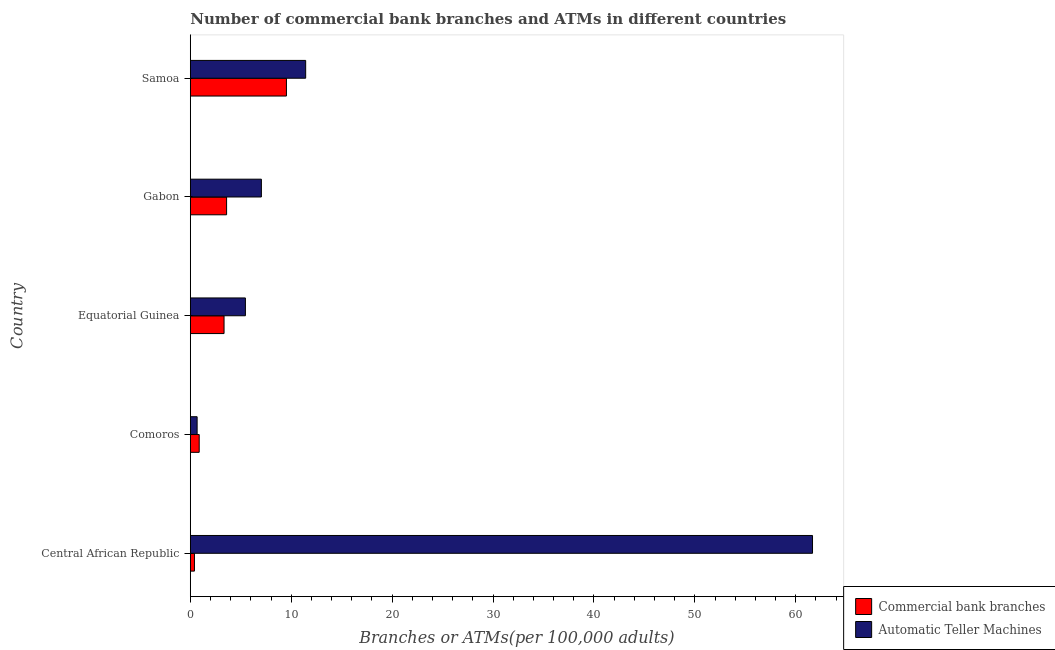Are the number of bars on each tick of the Y-axis equal?
Your response must be concise. Yes. How many bars are there on the 2nd tick from the top?
Make the answer very short. 2. What is the label of the 4th group of bars from the top?
Provide a succinct answer. Comoros. In how many cases, is the number of bars for a given country not equal to the number of legend labels?
Offer a very short reply. 0. What is the number of commercal bank branches in Central African Republic?
Offer a very short reply. 0.41. Across all countries, what is the maximum number of atms?
Your answer should be very brief. 61.66. Across all countries, what is the minimum number of atms?
Offer a very short reply. 0.68. In which country was the number of commercal bank branches maximum?
Give a very brief answer. Samoa. In which country was the number of atms minimum?
Your answer should be compact. Comoros. What is the total number of commercal bank branches in the graph?
Your response must be concise. 17.76. What is the difference between the number of commercal bank branches in Comoros and that in Equatorial Guinea?
Offer a very short reply. -2.46. What is the difference between the number of commercal bank branches in Equatorial Guinea and the number of atms in Central African Republic?
Offer a terse response. -58.31. What is the average number of commercal bank branches per country?
Your answer should be very brief. 3.55. What is the difference between the number of commercal bank branches and number of atms in Central African Republic?
Provide a succinct answer. -61.25. What is the ratio of the number of atms in Comoros to that in Samoa?
Your answer should be compact. 0.06. What is the difference between the highest and the second highest number of commercal bank branches?
Your response must be concise. 5.93. What is the difference between the highest and the lowest number of commercal bank branches?
Keep it short and to the point. 9.12. In how many countries, is the number of atms greater than the average number of atms taken over all countries?
Provide a short and direct response. 1. What does the 2nd bar from the top in Central African Republic represents?
Your response must be concise. Commercial bank branches. What does the 2nd bar from the bottom in Comoros represents?
Your answer should be compact. Automatic Teller Machines. Are all the bars in the graph horizontal?
Make the answer very short. Yes. What is the difference between two consecutive major ticks on the X-axis?
Ensure brevity in your answer.  10. Does the graph contain grids?
Your response must be concise. No. How are the legend labels stacked?
Your answer should be very brief. Vertical. What is the title of the graph?
Make the answer very short. Number of commercial bank branches and ATMs in different countries. Does "Net National savings" appear as one of the legend labels in the graph?
Give a very brief answer. No. What is the label or title of the X-axis?
Give a very brief answer. Branches or ATMs(per 100,0 adults). What is the label or title of the Y-axis?
Your answer should be very brief. Country. What is the Branches or ATMs(per 100,000 adults) of Commercial bank branches in Central African Republic?
Offer a very short reply. 0.41. What is the Branches or ATMs(per 100,000 adults) of Automatic Teller Machines in Central African Republic?
Ensure brevity in your answer.  61.66. What is the Branches or ATMs(per 100,000 adults) of Commercial bank branches in Comoros?
Ensure brevity in your answer.  0.88. What is the Branches or ATMs(per 100,000 adults) in Automatic Teller Machines in Comoros?
Offer a terse response. 0.68. What is the Branches or ATMs(per 100,000 adults) in Commercial bank branches in Equatorial Guinea?
Your answer should be very brief. 3.35. What is the Branches or ATMs(per 100,000 adults) in Automatic Teller Machines in Equatorial Guinea?
Make the answer very short. 5.46. What is the Branches or ATMs(per 100,000 adults) in Commercial bank branches in Gabon?
Make the answer very short. 3.6. What is the Branches or ATMs(per 100,000 adults) in Automatic Teller Machines in Gabon?
Give a very brief answer. 7.04. What is the Branches or ATMs(per 100,000 adults) of Commercial bank branches in Samoa?
Provide a succinct answer. 9.53. What is the Branches or ATMs(per 100,000 adults) of Automatic Teller Machines in Samoa?
Provide a short and direct response. 11.43. Across all countries, what is the maximum Branches or ATMs(per 100,000 adults) in Commercial bank branches?
Your answer should be compact. 9.53. Across all countries, what is the maximum Branches or ATMs(per 100,000 adults) of Automatic Teller Machines?
Offer a terse response. 61.66. Across all countries, what is the minimum Branches or ATMs(per 100,000 adults) in Commercial bank branches?
Offer a very short reply. 0.41. Across all countries, what is the minimum Branches or ATMs(per 100,000 adults) in Automatic Teller Machines?
Keep it short and to the point. 0.68. What is the total Branches or ATMs(per 100,000 adults) of Commercial bank branches in the graph?
Make the answer very short. 17.76. What is the total Branches or ATMs(per 100,000 adults) of Automatic Teller Machines in the graph?
Your response must be concise. 86.27. What is the difference between the Branches or ATMs(per 100,000 adults) of Commercial bank branches in Central African Republic and that in Comoros?
Keep it short and to the point. -0.47. What is the difference between the Branches or ATMs(per 100,000 adults) of Automatic Teller Machines in Central African Republic and that in Comoros?
Make the answer very short. 60.98. What is the difference between the Branches or ATMs(per 100,000 adults) of Commercial bank branches in Central African Republic and that in Equatorial Guinea?
Keep it short and to the point. -2.93. What is the difference between the Branches or ATMs(per 100,000 adults) in Automatic Teller Machines in Central African Republic and that in Equatorial Guinea?
Your response must be concise. 56.2. What is the difference between the Branches or ATMs(per 100,000 adults) of Commercial bank branches in Central African Republic and that in Gabon?
Make the answer very short. -3.19. What is the difference between the Branches or ATMs(per 100,000 adults) in Automatic Teller Machines in Central African Republic and that in Gabon?
Offer a terse response. 54.61. What is the difference between the Branches or ATMs(per 100,000 adults) of Commercial bank branches in Central African Republic and that in Samoa?
Ensure brevity in your answer.  -9.12. What is the difference between the Branches or ATMs(per 100,000 adults) of Automatic Teller Machines in Central African Republic and that in Samoa?
Ensure brevity in your answer.  50.22. What is the difference between the Branches or ATMs(per 100,000 adults) of Commercial bank branches in Comoros and that in Equatorial Guinea?
Keep it short and to the point. -2.46. What is the difference between the Branches or ATMs(per 100,000 adults) of Automatic Teller Machines in Comoros and that in Equatorial Guinea?
Offer a very short reply. -4.79. What is the difference between the Branches or ATMs(per 100,000 adults) in Commercial bank branches in Comoros and that in Gabon?
Your answer should be very brief. -2.71. What is the difference between the Branches or ATMs(per 100,000 adults) of Automatic Teller Machines in Comoros and that in Gabon?
Provide a succinct answer. -6.37. What is the difference between the Branches or ATMs(per 100,000 adults) in Commercial bank branches in Comoros and that in Samoa?
Provide a short and direct response. -8.64. What is the difference between the Branches or ATMs(per 100,000 adults) in Automatic Teller Machines in Comoros and that in Samoa?
Keep it short and to the point. -10.76. What is the difference between the Branches or ATMs(per 100,000 adults) in Commercial bank branches in Equatorial Guinea and that in Gabon?
Your answer should be very brief. -0.25. What is the difference between the Branches or ATMs(per 100,000 adults) of Automatic Teller Machines in Equatorial Guinea and that in Gabon?
Give a very brief answer. -1.58. What is the difference between the Branches or ATMs(per 100,000 adults) in Commercial bank branches in Equatorial Guinea and that in Samoa?
Your answer should be very brief. -6.18. What is the difference between the Branches or ATMs(per 100,000 adults) of Automatic Teller Machines in Equatorial Guinea and that in Samoa?
Keep it short and to the point. -5.97. What is the difference between the Branches or ATMs(per 100,000 adults) in Commercial bank branches in Gabon and that in Samoa?
Your answer should be very brief. -5.93. What is the difference between the Branches or ATMs(per 100,000 adults) in Automatic Teller Machines in Gabon and that in Samoa?
Provide a succinct answer. -4.39. What is the difference between the Branches or ATMs(per 100,000 adults) in Commercial bank branches in Central African Republic and the Branches or ATMs(per 100,000 adults) in Automatic Teller Machines in Comoros?
Make the answer very short. -0.26. What is the difference between the Branches or ATMs(per 100,000 adults) in Commercial bank branches in Central African Republic and the Branches or ATMs(per 100,000 adults) in Automatic Teller Machines in Equatorial Guinea?
Offer a very short reply. -5.05. What is the difference between the Branches or ATMs(per 100,000 adults) of Commercial bank branches in Central African Republic and the Branches or ATMs(per 100,000 adults) of Automatic Teller Machines in Gabon?
Give a very brief answer. -6.63. What is the difference between the Branches or ATMs(per 100,000 adults) in Commercial bank branches in Central African Republic and the Branches or ATMs(per 100,000 adults) in Automatic Teller Machines in Samoa?
Your response must be concise. -11.02. What is the difference between the Branches or ATMs(per 100,000 adults) of Commercial bank branches in Comoros and the Branches or ATMs(per 100,000 adults) of Automatic Teller Machines in Equatorial Guinea?
Offer a terse response. -4.58. What is the difference between the Branches or ATMs(per 100,000 adults) of Commercial bank branches in Comoros and the Branches or ATMs(per 100,000 adults) of Automatic Teller Machines in Gabon?
Make the answer very short. -6.16. What is the difference between the Branches or ATMs(per 100,000 adults) of Commercial bank branches in Comoros and the Branches or ATMs(per 100,000 adults) of Automatic Teller Machines in Samoa?
Your answer should be compact. -10.55. What is the difference between the Branches or ATMs(per 100,000 adults) of Commercial bank branches in Equatorial Guinea and the Branches or ATMs(per 100,000 adults) of Automatic Teller Machines in Gabon?
Make the answer very short. -3.7. What is the difference between the Branches or ATMs(per 100,000 adults) of Commercial bank branches in Equatorial Guinea and the Branches or ATMs(per 100,000 adults) of Automatic Teller Machines in Samoa?
Provide a short and direct response. -8.09. What is the difference between the Branches or ATMs(per 100,000 adults) in Commercial bank branches in Gabon and the Branches or ATMs(per 100,000 adults) in Automatic Teller Machines in Samoa?
Give a very brief answer. -7.84. What is the average Branches or ATMs(per 100,000 adults) of Commercial bank branches per country?
Offer a terse response. 3.55. What is the average Branches or ATMs(per 100,000 adults) in Automatic Teller Machines per country?
Give a very brief answer. 17.25. What is the difference between the Branches or ATMs(per 100,000 adults) in Commercial bank branches and Branches or ATMs(per 100,000 adults) in Automatic Teller Machines in Central African Republic?
Give a very brief answer. -61.25. What is the difference between the Branches or ATMs(per 100,000 adults) of Commercial bank branches and Branches or ATMs(per 100,000 adults) of Automatic Teller Machines in Comoros?
Keep it short and to the point. 0.21. What is the difference between the Branches or ATMs(per 100,000 adults) in Commercial bank branches and Branches or ATMs(per 100,000 adults) in Automatic Teller Machines in Equatorial Guinea?
Give a very brief answer. -2.12. What is the difference between the Branches or ATMs(per 100,000 adults) in Commercial bank branches and Branches or ATMs(per 100,000 adults) in Automatic Teller Machines in Gabon?
Provide a short and direct response. -3.45. What is the difference between the Branches or ATMs(per 100,000 adults) in Commercial bank branches and Branches or ATMs(per 100,000 adults) in Automatic Teller Machines in Samoa?
Offer a terse response. -1.91. What is the ratio of the Branches or ATMs(per 100,000 adults) in Commercial bank branches in Central African Republic to that in Comoros?
Provide a succinct answer. 0.47. What is the ratio of the Branches or ATMs(per 100,000 adults) of Automatic Teller Machines in Central African Republic to that in Comoros?
Provide a short and direct response. 91.18. What is the ratio of the Branches or ATMs(per 100,000 adults) in Commercial bank branches in Central African Republic to that in Equatorial Guinea?
Provide a succinct answer. 0.12. What is the ratio of the Branches or ATMs(per 100,000 adults) of Automatic Teller Machines in Central African Republic to that in Equatorial Guinea?
Your response must be concise. 11.29. What is the ratio of the Branches or ATMs(per 100,000 adults) of Commercial bank branches in Central African Republic to that in Gabon?
Your answer should be very brief. 0.11. What is the ratio of the Branches or ATMs(per 100,000 adults) of Automatic Teller Machines in Central African Republic to that in Gabon?
Ensure brevity in your answer.  8.75. What is the ratio of the Branches or ATMs(per 100,000 adults) of Commercial bank branches in Central African Republic to that in Samoa?
Your answer should be very brief. 0.04. What is the ratio of the Branches or ATMs(per 100,000 adults) in Automatic Teller Machines in Central African Republic to that in Samoa?
Provide a short and direct response. 5.39. What is the ratio of the Branches or ATMs(per 100,000 adults) of Commercial bank branches in Comoros to that in Equatorial Guinea?
Your response must be concise. 0.26. What is the ratio of the Branches or ATMs(per 100,000 adults) in Automatic Teller Machines in Comoros to that in Equatorial Guinea?
Keep it short and to the point. 0.12. What is the ratio of the Branches or ATMs(per 100,000 adults) of Commercial bank branches in Comoros to that in Gabon?
Ensure brevity in your answer.  0.25. What is the ratio of the Branches or ATMs(per 100,000 adults) in Automatic Teller Machines in Comoros to that in Gabon?
Provide a succinct answer. 0.1. What is the ratio of the Branches or ATMs(per 100,000 adults) of Commercial bank branches in Comoros to that in Samoa?
Ensure brevity in your answer.  0.09. What is the ratio of the Branches or ATMs(per 100,000 adults) in Automatic Teller Machines in Comoros to that in Samoa?
Keep it short and to the point. 0.06. What is the ratio of the Branches or ATMs(per 100,000 adults) of Commercial bank branches in Equatorial Guinea to that in Gabon?
Make the answer very short. 0.93. What is the ratio of the Branches or ATMs(per 100,000 adults) of Automatic Teller Machines in Equatorial Guinea to that in Gabon?
Your answer should be compact. 0.78. What is the ratio of the Branches or ATMs(per 100,000 adults) of Commercial bank branches in Equatorial Guinea to that in Samoa?
Make the answer very short. 0.35. What is the ratio of the Branches or ATMs(per 100,000 adults) of Automatic Teller Machines in Equatorial Guinea to that in Samoa?
Give a very brief answer. 0.48. What is the ratio of the Branches or ATMs(per 100,000 adults) in Commercial bank branches in Gabon to that in Samoa?
Your response must be concise. 0.38. What is the ratio of the Branches or ATMs(per 100,000 adults) in Automatic Teller Machines in Gabon to that in Samoa?
Your answer should be very brief. 0.62. What is the difference between the highest and the second highest Branches or ATMs(per 100,000 adults) in Commercial bank branches?
Give a very brief answer. 5.93. What is the difference between the highest and the second highest Branches or ATMs(per 100,000 adults) of Automatic Teller Machines?
Your response must be concise. 50.22. What is the difference between the highest and the lowest Branches or ATMs(per 100,000 adults) in Commercial bank branches?
Your answer should be compact. 9.12. What is the difference between the highest and the lowest Branches or ATMs(per 100,000 adults) of Automatic Teller Machines?
Your answer should be compact. 60.98. 